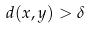<formula> <loc_0><loc_0><loc_500><loc_500>d ( x , y ) > \delta</formula> 